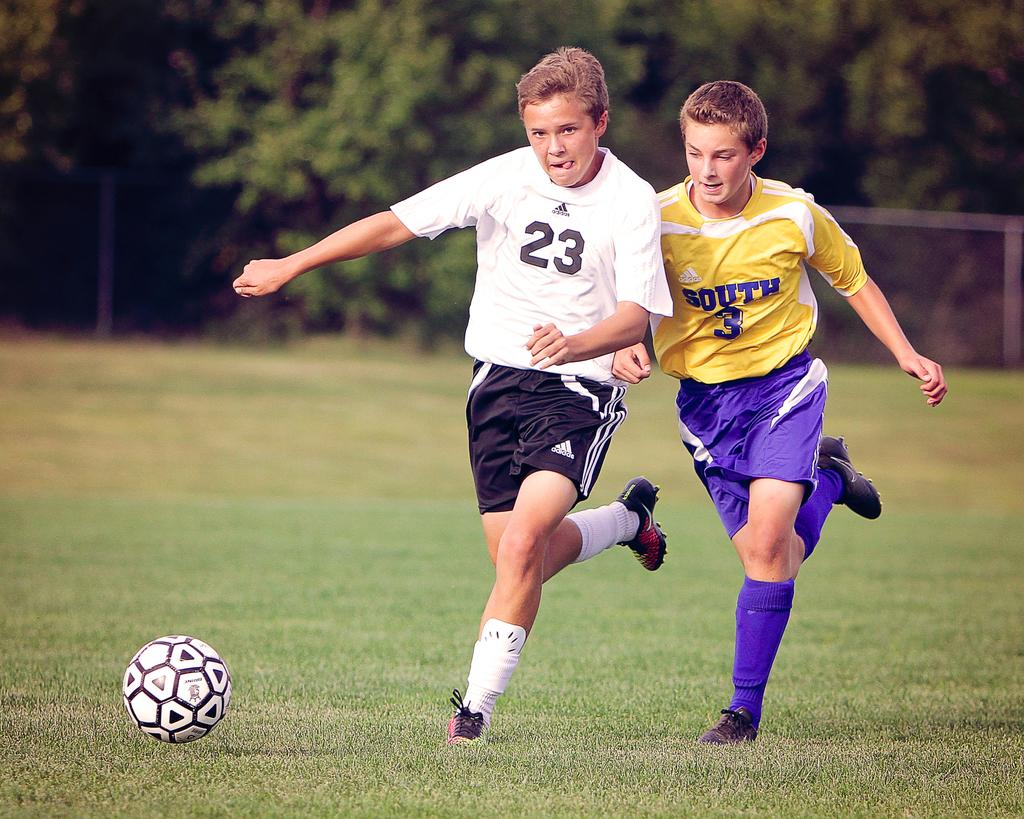<image>
Provide a brief description of the given image. the number 23 is on the jersey of a person 